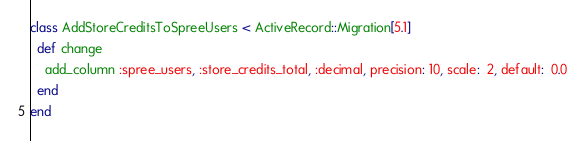Convert code to text. <code><loc_0><loc_0><loc_500><loc_500><_Ruby_>class AddStoreCreditsToSpreeUsers < ActiveRecord::Migration[5.1]
  def change
    add_column :spree_users, :store_credits_total, :decimal, precision: 10, scale:  2, default:  0.0
  end
end
</code> 